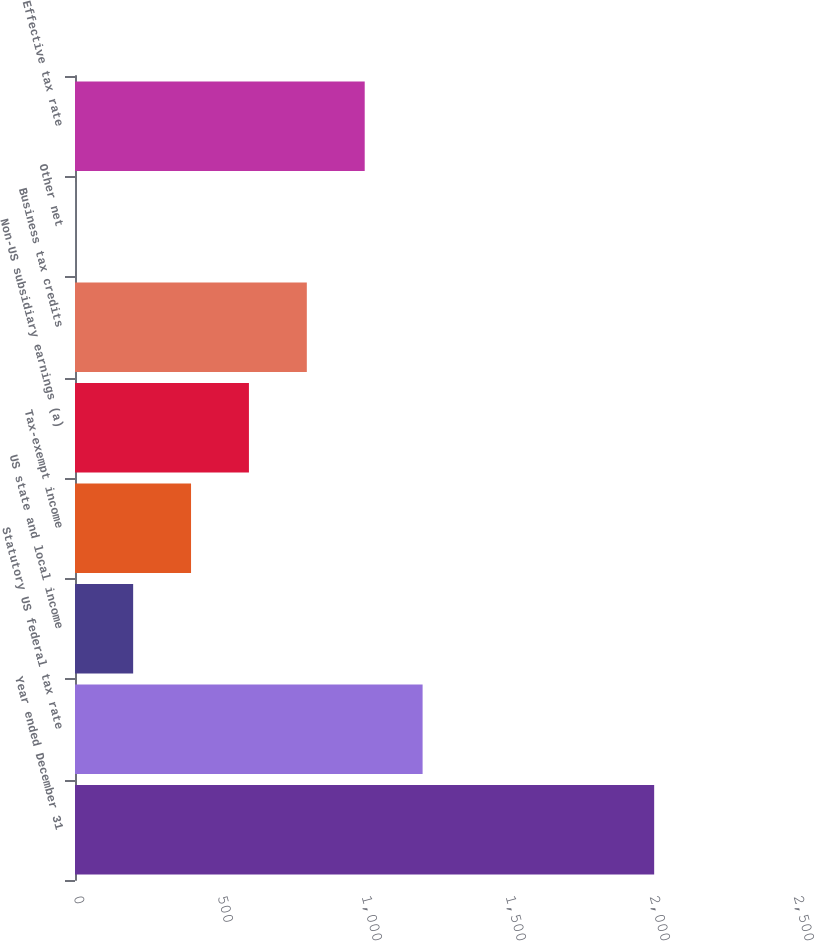<chart> <loc_0><loc_0><loc_500><loc_500><bar_chart><fcel>Year ended December 31<fcel>Statutory US federal tax rate<fcel>US state and local income<fcel>Tax-exempt income<fcel>Non-US subsidiary earnings (a)<fcel>Business tax credits<fcel>Other net<fcel>Effective tax rate<nl><fcel>2011<fcel>1206.96<fcel>201.91<fcel>402.92<fcel>603.93<fcel>804.94<fcel>0.9<fcel>1005.95<nl></chart> 